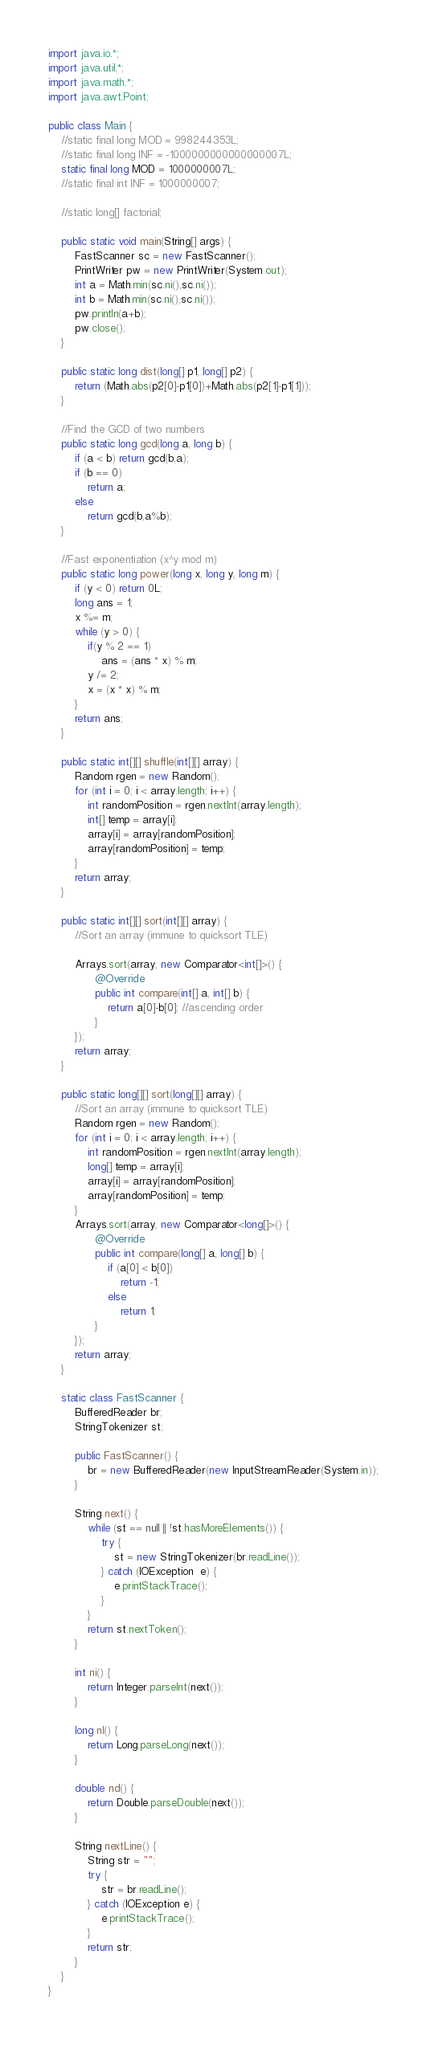Convert code to text. <code><loc_0><loc_0><loc_500><loc_500><_Java_>import java.io.*;
import java.util.*;
import java.math.*;
import java.awt.Point;
 
public class Main {
	//static final long MOD = 998244353L;
	//static final long INF = -1000000000000000007L;
	static final long MOD = 1000000007L;
	//static final int INF = 1000000007;
	
	//static long[] factorial;
	
	public static void main(String[] args) {
		FastScanner sc = new FastScanner();
		PrintWriter pw = new PrintWriter(System.out);
		int a = Math.min(sc.ni(),sc.ni());
		int b = Math.min(sc.ni(),sc.ni());
		pw.println(a+b);
		pw.close();
	}
	
	public static long dist(long[] p1, long[] p2) {
		return (Math.abs(p2[0]-p1[0])+Math.abs(p2[1]-p1[1]));
	}
	
	//Find the GCD of two numbers
	public static long gcd(long a, long b) {
		if (a < b) return gcd(b,a);
		if (b == 0)
			return a;
		else
			return gcd(b,a%b);
	}
	
	//Fast exponentiation (x^y mod m)
	public static long power(long x, long y, long m) { 
		if (y < 0) return 0L;
		long ans = 1;
		x %= m;
		while (y > 0) { 
			if(y % 2 == 1) 
				ans = (ans * x) % m; 
			y /= 2;  
			x = (x * x) % m;
		} 
		return ans; 
	}
	
	public static int[][] shuffle(int[][] array) {
		Random rgen = new Random();
		for (int i = 0; i < array.length; i++) {
		    int randomPosition = rgen.nextInt(array.length);
		    int[] temp = array[i];
		    array[i] = array[randomPosition];
		    array[randomPosition] = temp;
		}
		return array;
	}
	
    public static int[][] sort(int[][] array) {
    	//Sort an array (immune to quicksort TLE)
 
		Arrays.sort(array, new Comparator<int[]>() {
			  @Override
        	  public int compare(int[] a, int[] b) {
				  return a[0]-b[0]; //ascending order
	          }
		});
		return array;
	}
    
    public static long[][] sort(long[][] array) {
    	//Sort an array (immune to quicksort TLE)
		Random rgen = new Random();
		for (int i = 0; i < array.length; i++) {
		    int randomPosition = rgen.nextInt(array.length);
		    long[] temp = array[i];
		    array[i] = array[randomPosition];
		    array[randomPosition] = temp;
		}
		Arrays.sort(array, new Comparator<long[]>() {
			  @Override
        	  public int compare(long[] a, long[] b) {
				  if (a[0] < b[0])
					  return -1;
				  else
					  return 1;
	          }
		});
		return array;
	}
    
    static class FastScanner { 
        BufferedReader br; 
        StringTokenizer st; 
  
        public FastScanner() { 
            br = new BufferedReader(new InputStreamReader(System.in)); 
        } 
  
        String next() { 
            while (st == null || !st.hasMoreElements()) { 
                try { 
                    st = new StringTokenizer(br.readLine());
                } catch (IOException  e) { 
                    e.printStackTrace(); 
                } 
            } 
            return st.nextToken(); 
        } 
  
        int ni() { 
            return Integer.parseInt(next()); 
        } 
  
        long nl() { 
            return Long.parseLong(next()); 
        } 
  
        double nd() { 
            return Double.parseDouble(next()); 
        } 
  
        String nextLine() { 
            String str = ""; 
            try { 
                str = br.readLine(); 
            } catch (IOException e) {
                e.printStackTrace(); 
            } 
            return str;
        }
    }
}</code> 